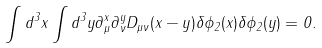Convert formula to latex. <formula><loc_0><loc_0><loc_500><loc_500>\int d ^ { 3 } x \int d ^ { 3 } y \partial _ { \mu } ^ { x } \partial _ { \nu } ^ { y } D _ { \mu \nu } ( x - y ) \delta \phi _ { 2 } ( x ) \delta \phi _ { 2 } ( y ) = 0 .</formula> 